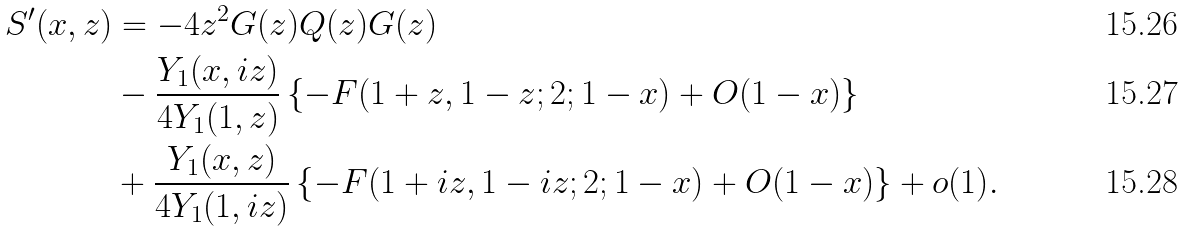<formula> <loc_0><loc_0><loc_500><loc_500>S ^ { \prime } ( x , z ) & = - 4 z ^ { 2 } G ( z ) Q ( z ) G ( z ) \\ & - \frac { Y _ { 1 } ( x , i z ) } { 4 Y _ { 1 } ( 1 , z ) } \left \{ - F ( 1 + z , 1 - z ; 2 ; 1 - x ) + O ( 1 - x ) \right \} \\ & + \frac { Y _ { 1 } ( x , z ) } { 4 Y _ { 1 } ( 1 , i z ) } \left \{ - F ( 1 + i z , 1 - i z ; 2 ; 1 - x ) + O ( 1 - x ) \right \} + o ( 1 ) .</formula> 